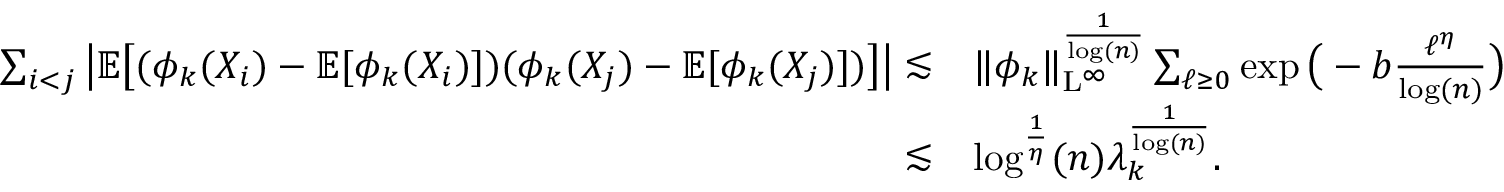<formula> <loc_0><loc_0><loc_500><loc_500>\begin{array} { r l } { \sum _ { i < j } \left | \mathbb { E } \left [ ( \phi _ { k } ( X _ { i } ) - \mathbb { E } [ \phi _ { k } ( X _ { i } ) ] ) ( \phi _ { k } ( X _ { j } ) - \mathbb { E } [ \phi _ { k } ( X _ { j } ) ] ) \right ] \right | \lesssim } & { \| \phi _ { k } \| _ { L ^ { \infty } } ^ { \frac { 1 } { \log ( n ) } } \sum _ { \ell \geq 0 } \exp \left ( - b \frac { \ell ^ { \eta } } { \log ( n ) } \right ) } \\ { \lesssim } & { \log ^ { \frac { 1 } { \eta } } ( n ) \lambda _ { k } ^ { \frac { 1 } { \log ( n ) } } . } \end{array}</formula> 